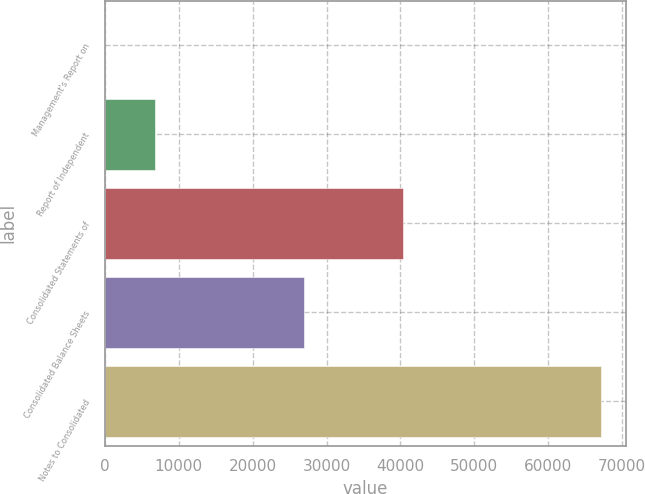Convert chart. <chart><loc_0><loc_0><loc_500><loc_500><bar_chart><fcel>Management's Report on<fcel>Report of Independent<fcel>Consolidated Statements of<fcel>Consolidated Balance Sheets<fcel>Notes to Consolidated<nl><fcel>58<fcel>6763.3<fcel>40289.8<fcel>26879.2<fcel>67111<nl></chart> 